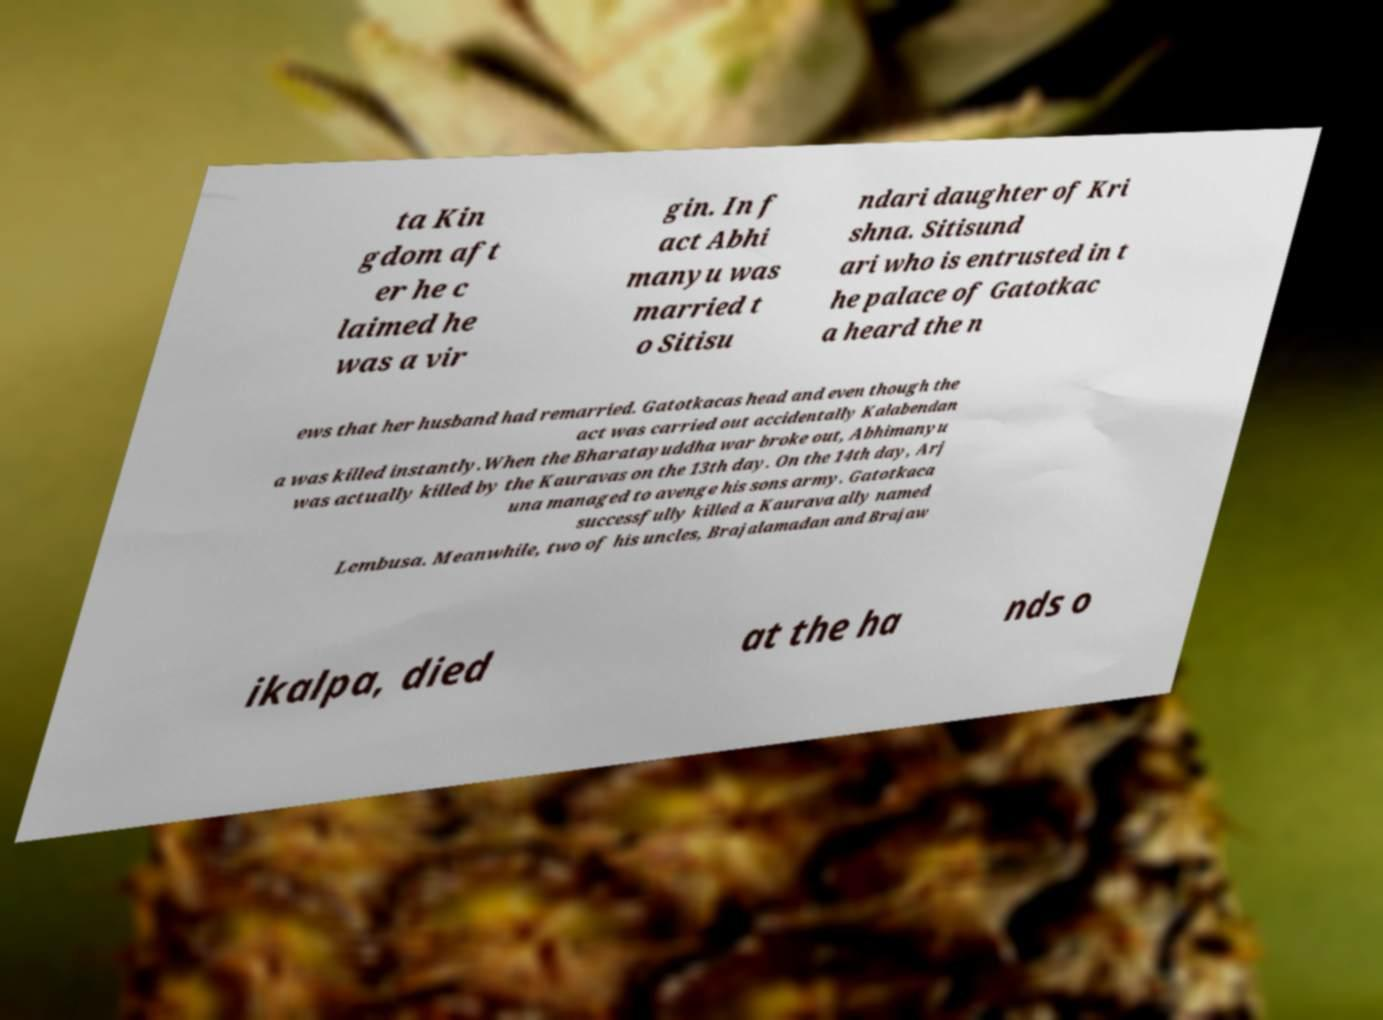Can you accurately transcribe the text from the provided image for me? ta Kin gdom aft er he c laimed he was a vir gin. In f act Abhi manyu was married t o Sitisu ndari daughter of Kri shna. Sitisund ari who is entrusted in t he palace of Gatotkac a heard the n ews that her husband had remarried. Gatotkacas head and even though the act was carried out accidentally Kalabendan a was killed instantly.When the Bharatayuddha war broke out, Abhimanyu was actually killed by the Kauravas on the 13th day. On the 14th day, Arj una managed to avenge his sons army. Gatotkaca successfully killed a Kaurava ally named Lembusa. Meanwhile, two of his uncles, Brajalamadan and Brajaw ikalpa, died at the ha nds o 